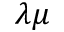Convert formula to latex. <formula><loc_0><loc_0><loc_500><loc_500>\lambda \mu</formula> 